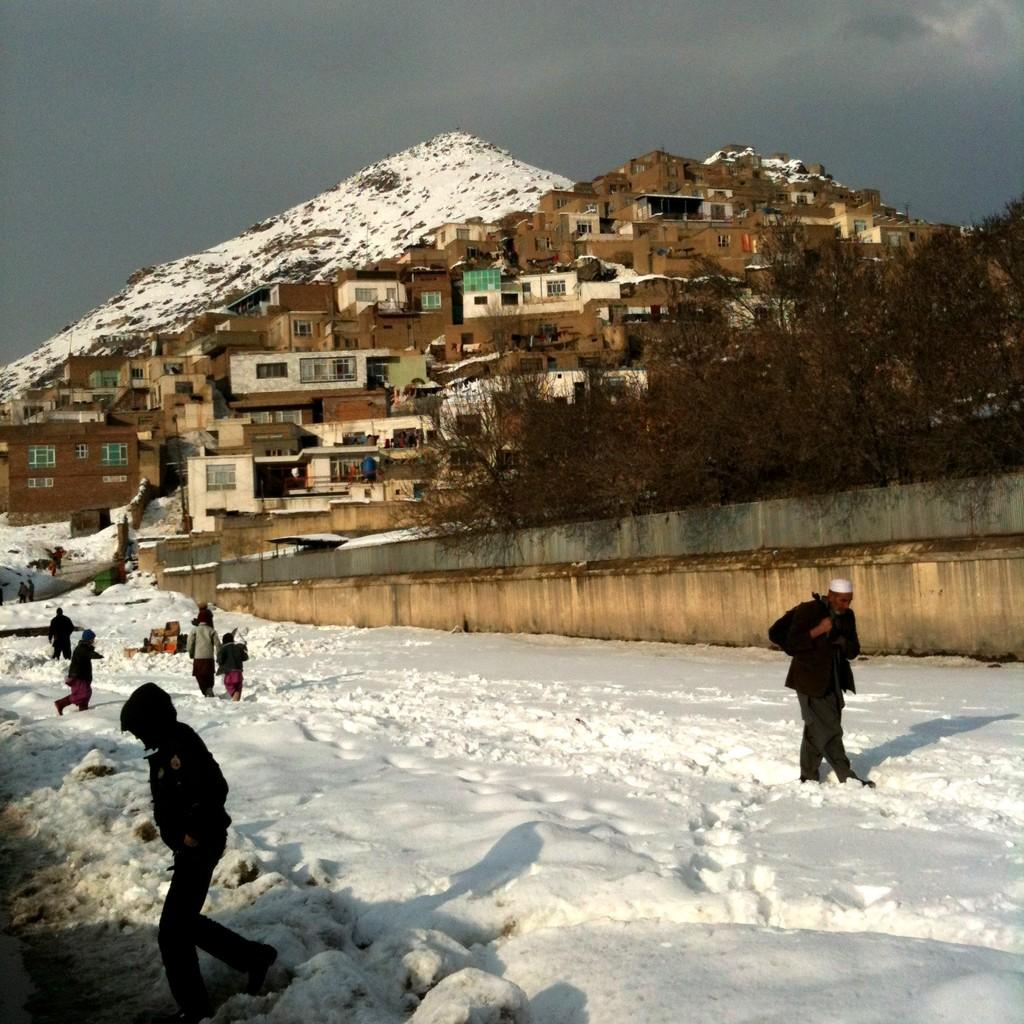What is the main feature of the landscape in the image? There is snow in the image. Can you describe the people in the image? There is a group of people standing in the image. What structures can be seen in the image? There are buildings visible in the image. What type of vegetation is present in the image? Trees are present in the image. What is the prominent geographical feature in the image? There is a snowy mountain in the image. What is visible in the background of the image? The sky is visible in the background of the image. What type of pizzas are being served to the group of people in the image? There are no pizzas present in the image; it features a group of people standing in the snow. What color is the orange that is being used by the group of people in the image? There is no orange present in the image; it features a group of people standing in the snow. 